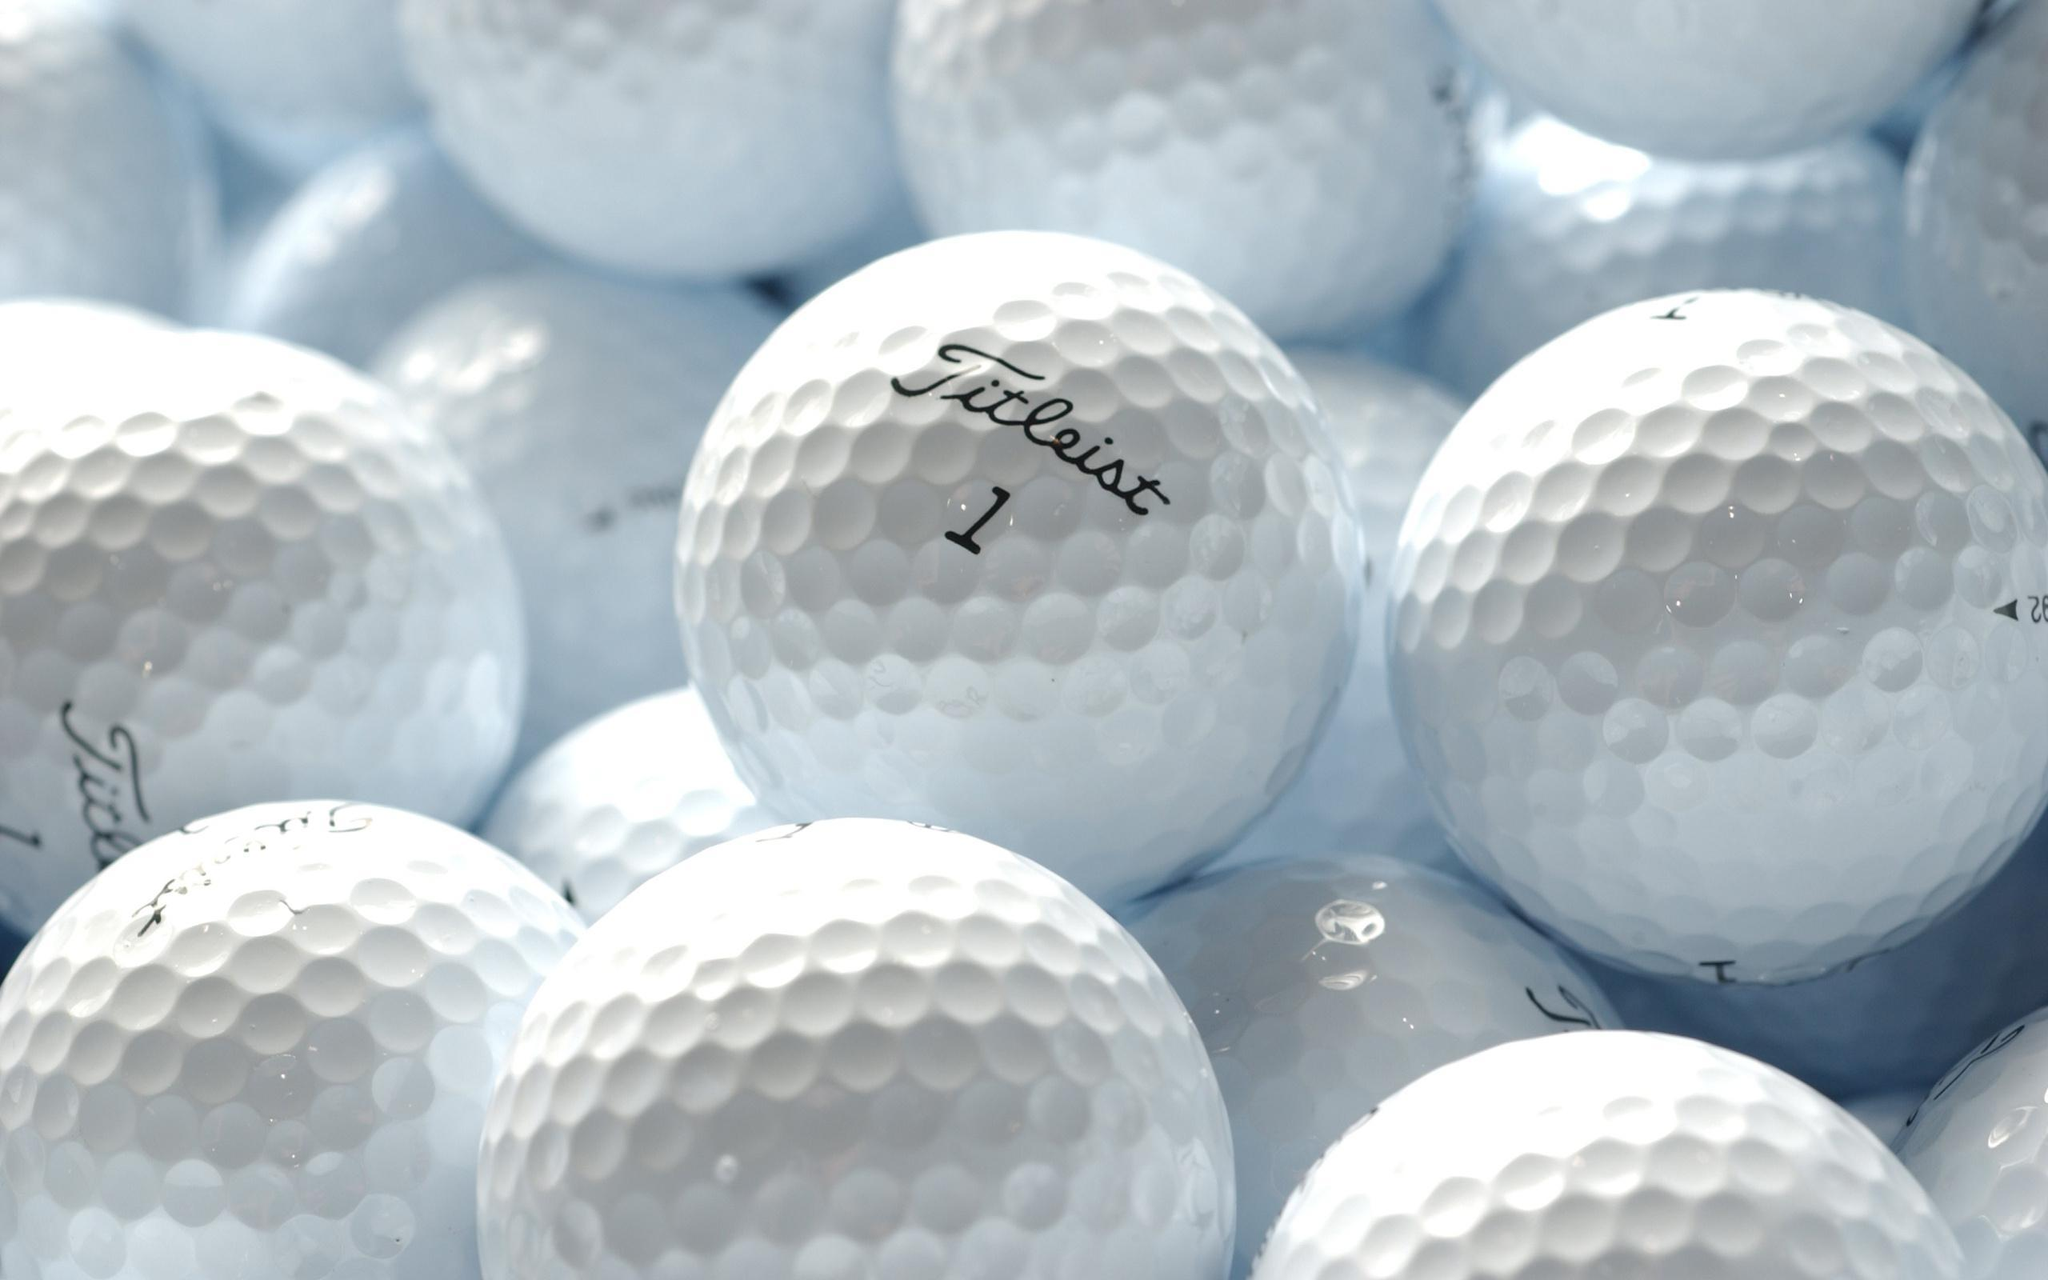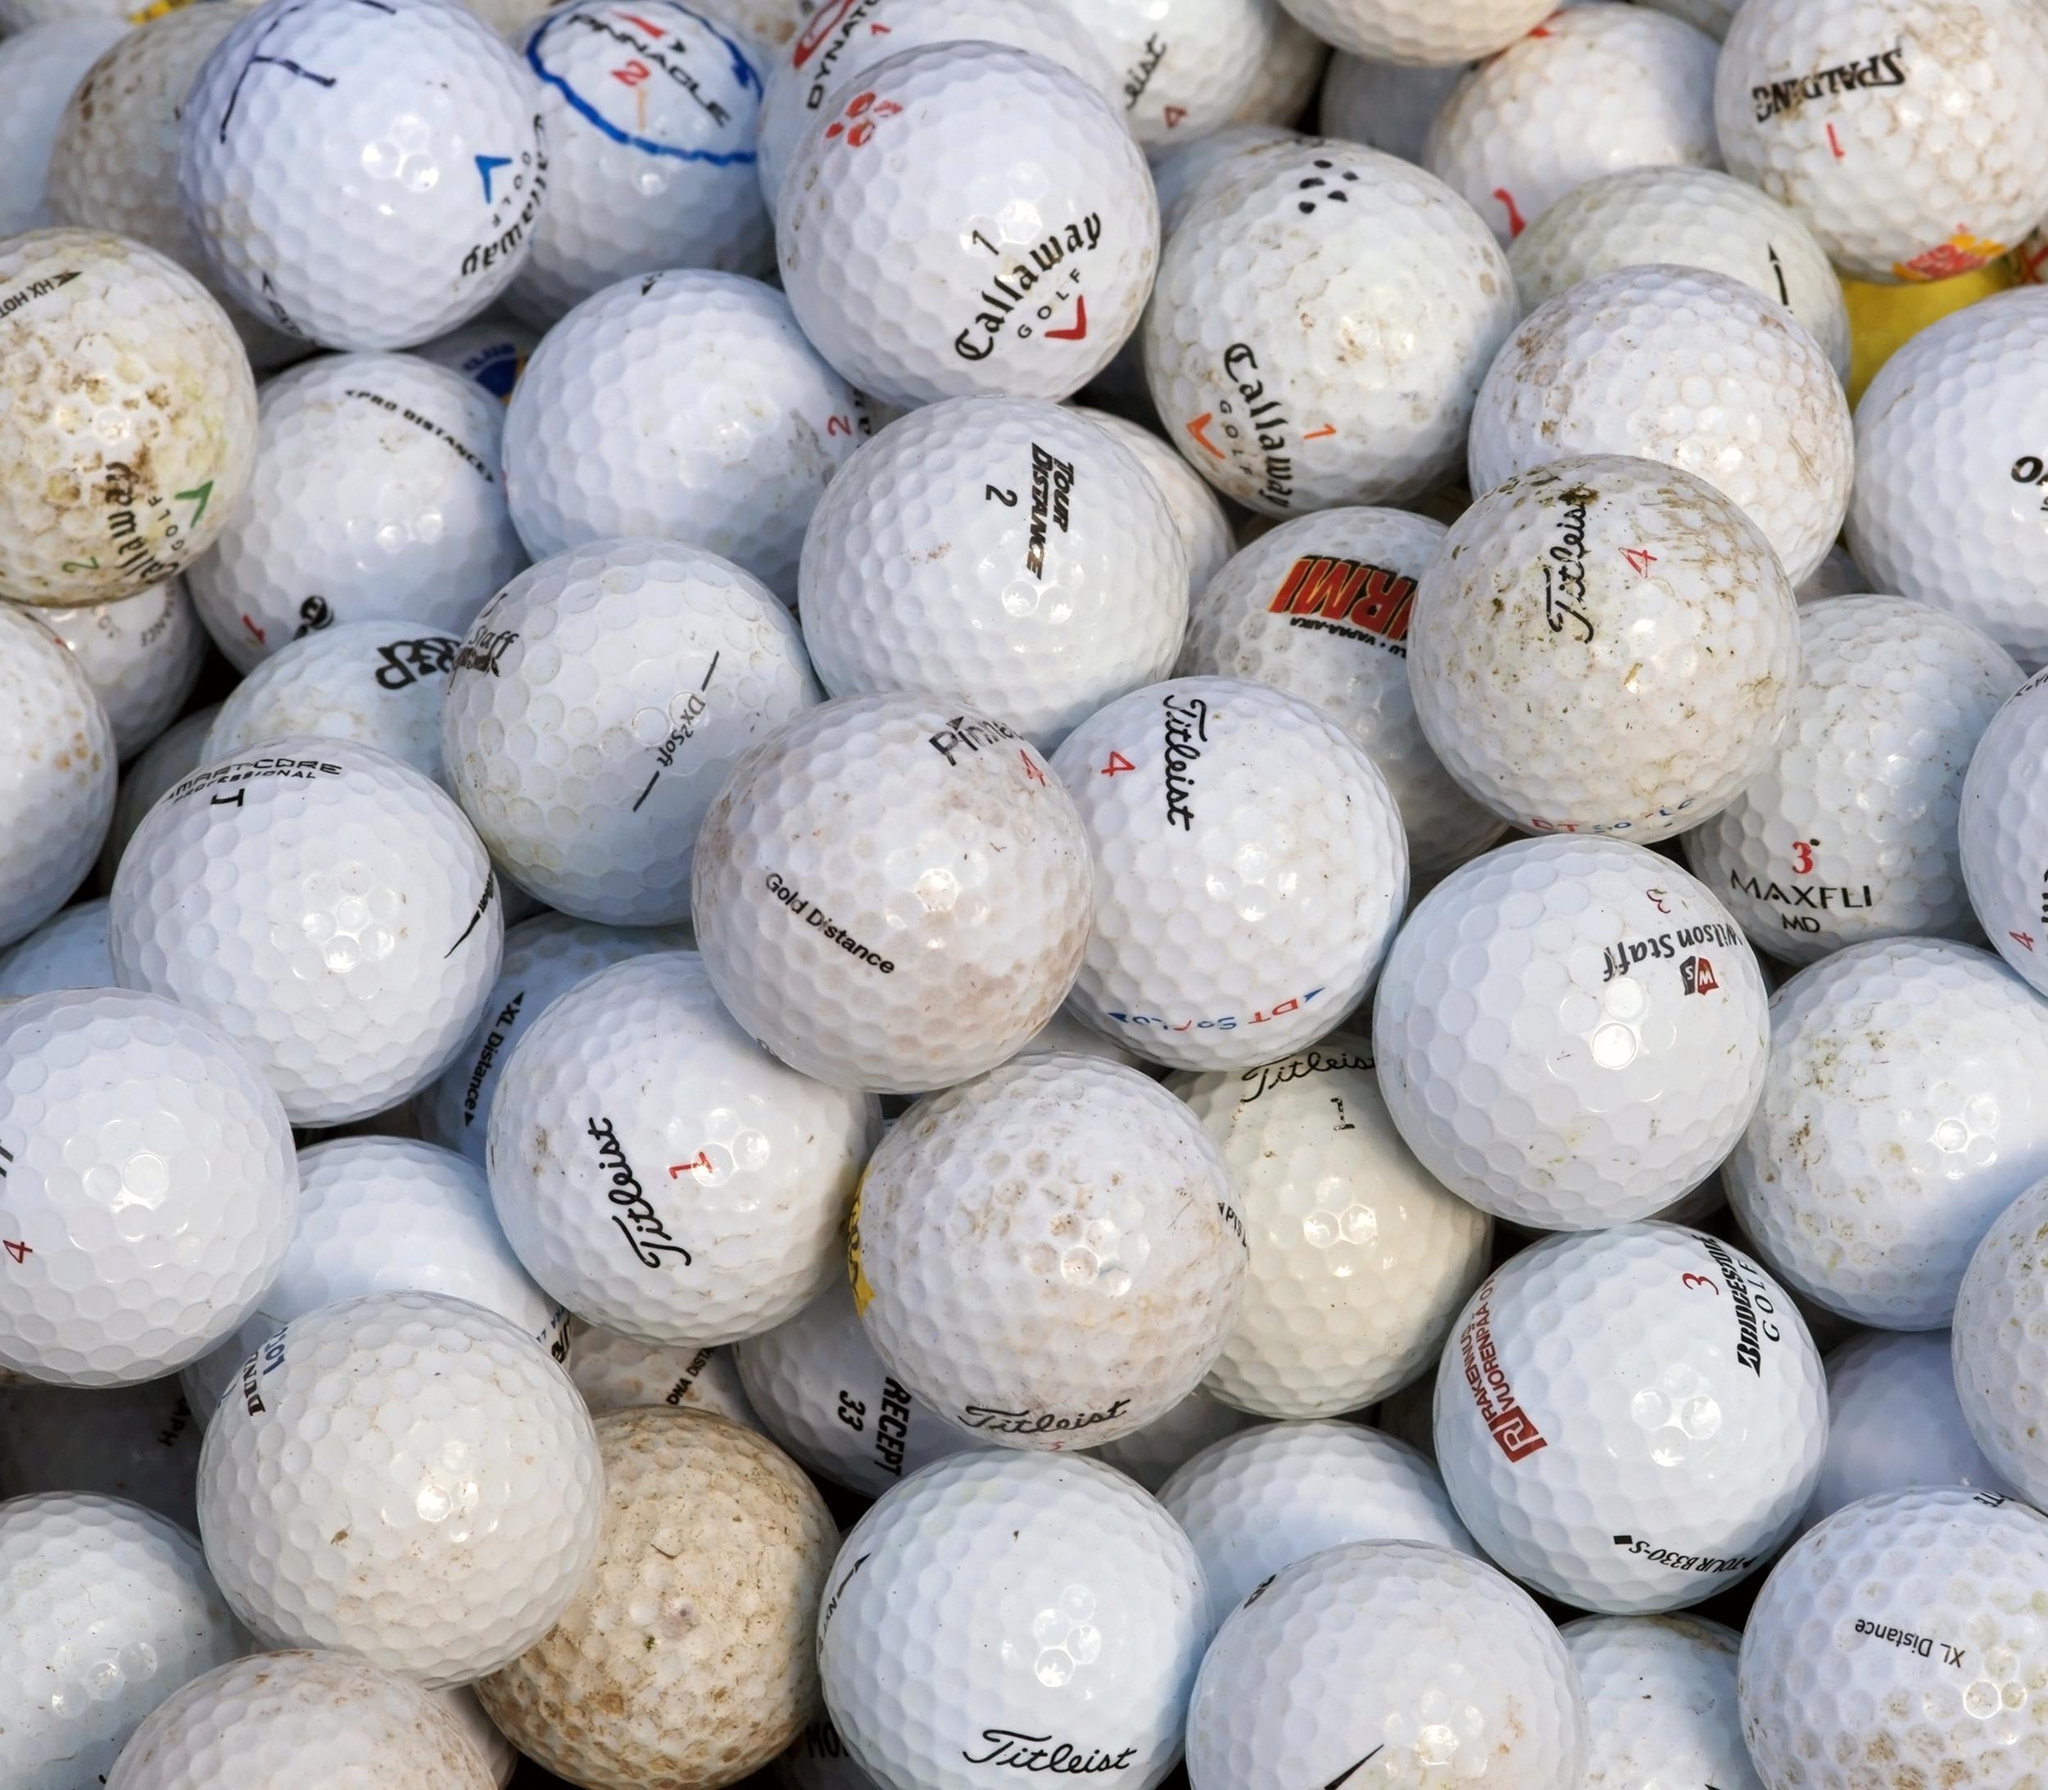The first image is the image on the left, the second image is the image on the right. Analyze the images presented: Is the assertion "At least one image has exactly one golf ball." valid? Answer yes or no. No. The first image is the image on the left, the second image is the image on the right. Examine the images to the left and right. Is the description "Only one golf ball is depicted on at least one image." accurate? Answer yes or no. No. 